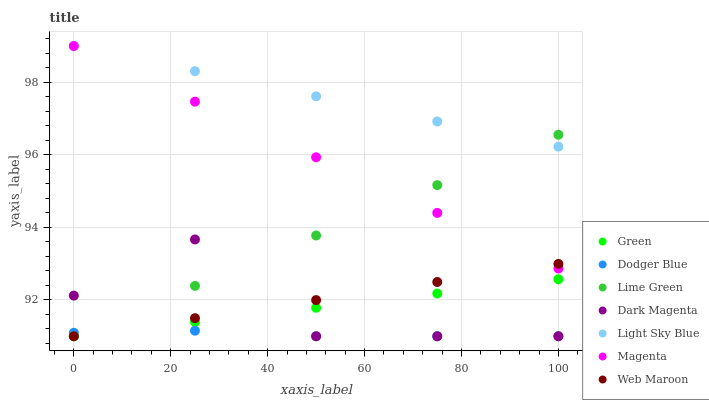Does Dodger Blue have the minimum area under the curve?
Answer yes or no. Yes. Does Light Sky Blue have the maximum area under the curve?
Answer yes or no. Yes. Does Web Maroon have the minimum area under the curve?
Answer yes or no. No. Does Web Maroon have the maximum area under the curve?
Answer yes or no. No. Is Web Maroon the smoothest?
Answer yes or no. Yes. Is Dark Magenta the roughest?
Answer yes or no. Yes. Is Dodger Blue the smoothest?
Answer yes or no. No. Is Dodger Blue the roughest?
Answer yes or no. No. Does Dark Magenta have the lowest value?
Answer yes or no. Yes. Does Light Sky Blue have the lowest value?
Answer yes or no. No. Does Magenta have the highest value?
Answer yes or no. Yes. Does Web Maroon have the highest value?
Answer yes or no. No. Is Green less than Magenta?
Answer yes or no. Yes. Is Magenta greater than Dodger Blue?
Answer yes or no. Yes. Does Green intersect Dodger Blue?
Answer yes or no. Yes. Is Green less than Dodger Blue?
Answer yes or no. No. Is Green greater than Dodger Blue?
Answer yes or no. No. Does Green intersect Magenta?
Answer yes or no. No. 